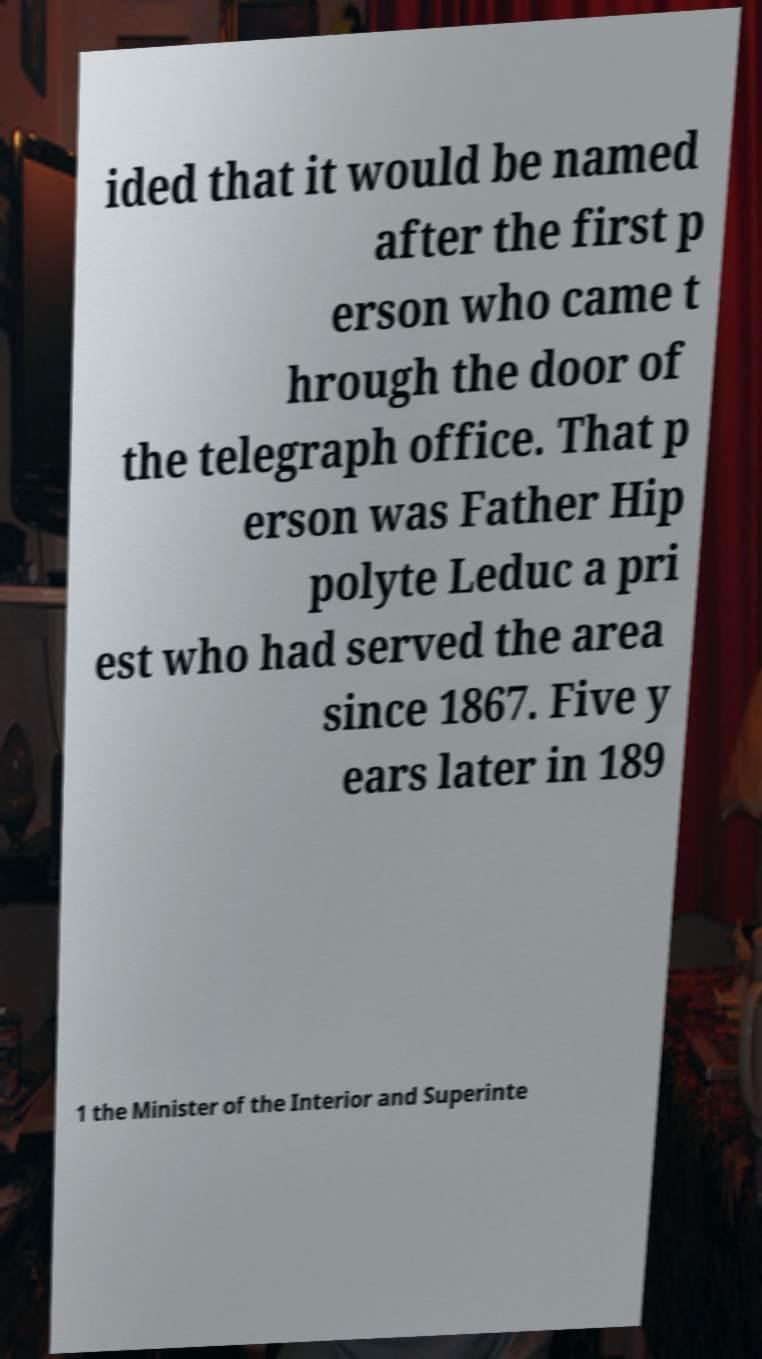Please identify and transcribe the text found in this image. ided that it would be named after the first p erson who came t hrough the door of the telegraph office. That p erson was Father Hip polyte Leduc a pri est who had served the area since 1867. Five y ears later in 189 1 the Minister of the Interior and Superinte 